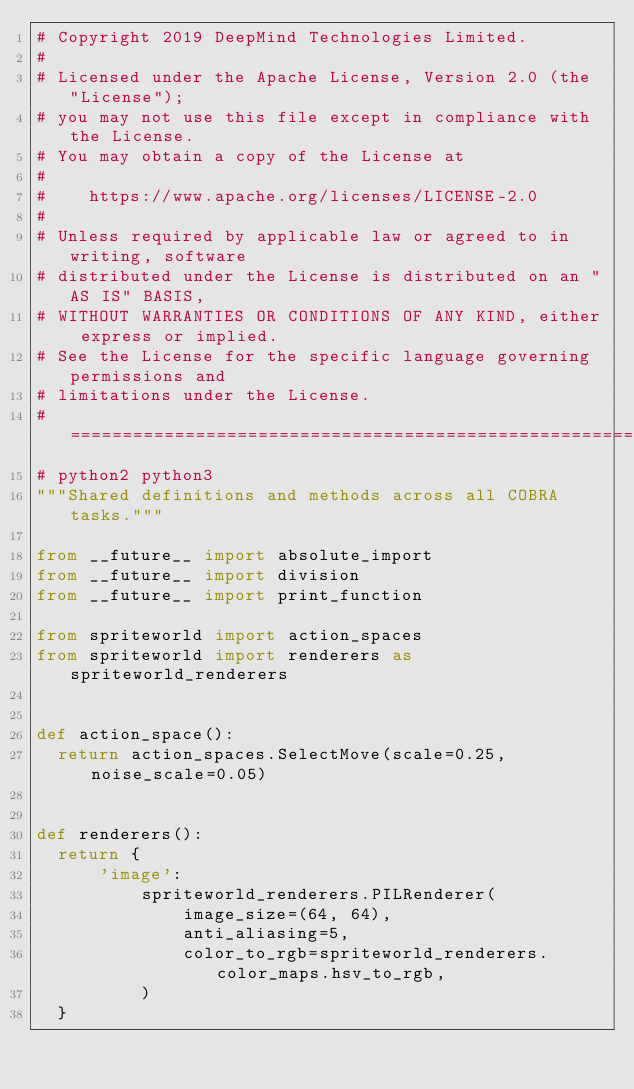Convert code to text. <code><loc_0><loc_0><loc_500><loc_500><_Python_># Copyright 2019 DeepMind Technologies Limited.
#
# Licensed under the Apache License, Version 2.0 (the "License");
# you may not use this file except in compliance with the License.
# You may obtain a copy of the License at
#
#    https://www.apache.org/licenses/LICENSE-2.0
#
# Unless required by applicable law or agreed to in writing, software
# distributed under the License is distributed on an "AS IS" BASIS,
# WITHOUT WARRANTIES OR CONDITIONS OF ANY KIND, either express or implied.
# See the License for the specific language governing permissions and
# limitations under the License.
# ============================================================================
# python2 python3
"""Shared definitions and methods across all COBRA tasks."""

from __future__ import absolute_import
from __future__ import division
from __future__ import print_function

from spriteworld import action_spaces
from spriteworld import renderers as spriteworld_renderers


def action_space():
  return action_spaces.SelectMove(scale=0.25, noise_scale=0.05)


def renderers():
  return {
      'image':
          spriteworld_renderers.PILRenderer(
              image_size=(64, 64),
              anti_aliasing=5,
              color_to_rgb=spriteworld_renderers.color_maps.hsv_to_rgb,
          )
  }
</code> 